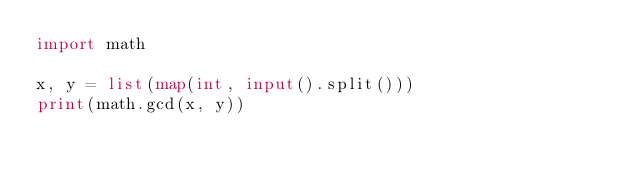Convert code to text. <code><loc_0><loc_0><loc_500><loc_500><_Python_>import math

x, y = list(map(int, input().split()))
print(math.gcd(x, y))
</code> 